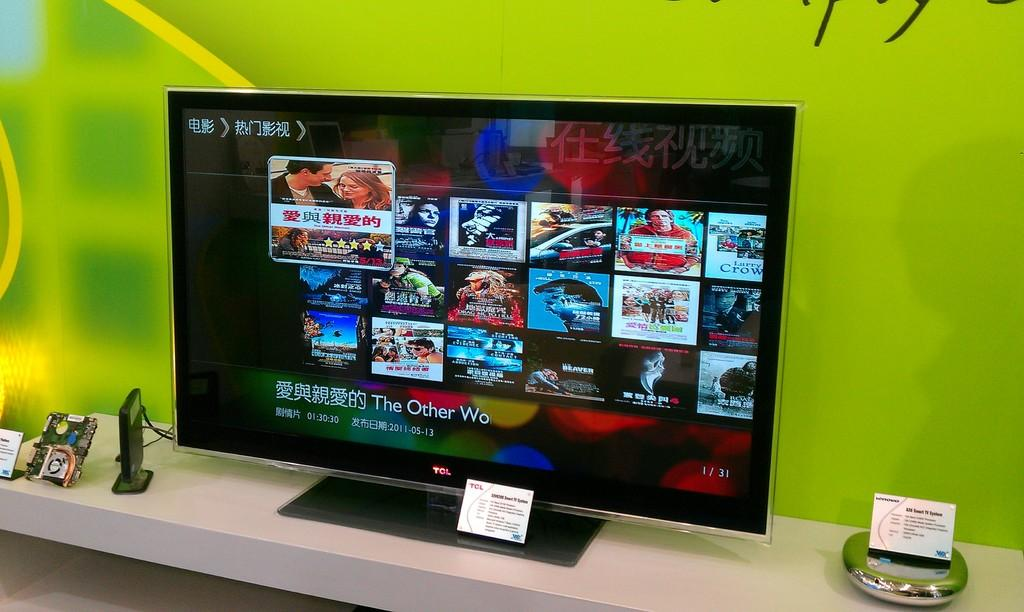<image>
Write a terse but informative summary of the picture. A card with the letters TCL is propped in front of a screen showing video selections. 